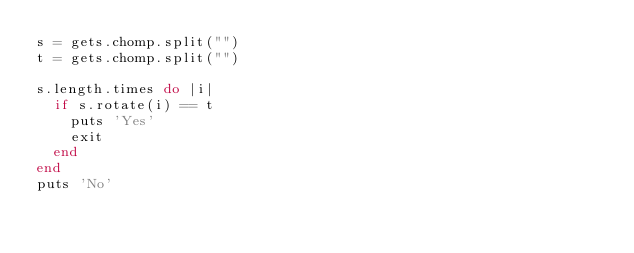Convert code to text. <code><loc_0><loc_0><loc_500><loc_500><_Ruby_>s = gets.chomp.split("")
t = gets.chomp.split("")

s.length.times do |i|
  if s.rotate(i) == t
    puts 'Yes'
    exit
  end
end
puts 'No'</code> 